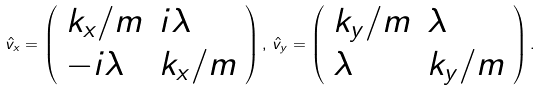<formula> <loc_0><loc_0><loc_500><loc_500>\hat { v } _ { x } = \left ( \begin{array} { l l } k _ { x } / m & i \lambda \\ - i \lambda & k _ { x } / m \end{array} \right ) , \, \hat { v } _ { y } = \left ( \begin{array} { l l } k _ { y } / m & \lambda \\ \lambda & k _ { y } / m \end{array} \right ) .</formula> 